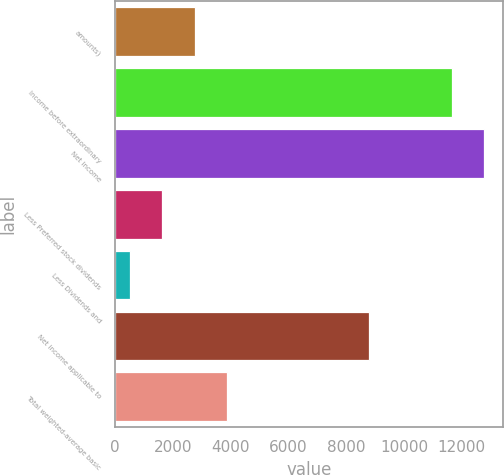Convert chart. <chart><loc_0><loc_0><loc_500><loc_500><bar_chart><fcel>amounts)<fcel>Income before extraordinary<fcel>Net income<fcel>Less Preferred stock dividends<fcel>Less Dividends and<fcel>Net income applicable to<fcel>Total weighted-average basic<nl><fcel>2757.6<fcel>11652<fcel>12773.3<fcel>1636.3<fcel>515<fcel>8774<fcel>3878.9<nl></chart> 